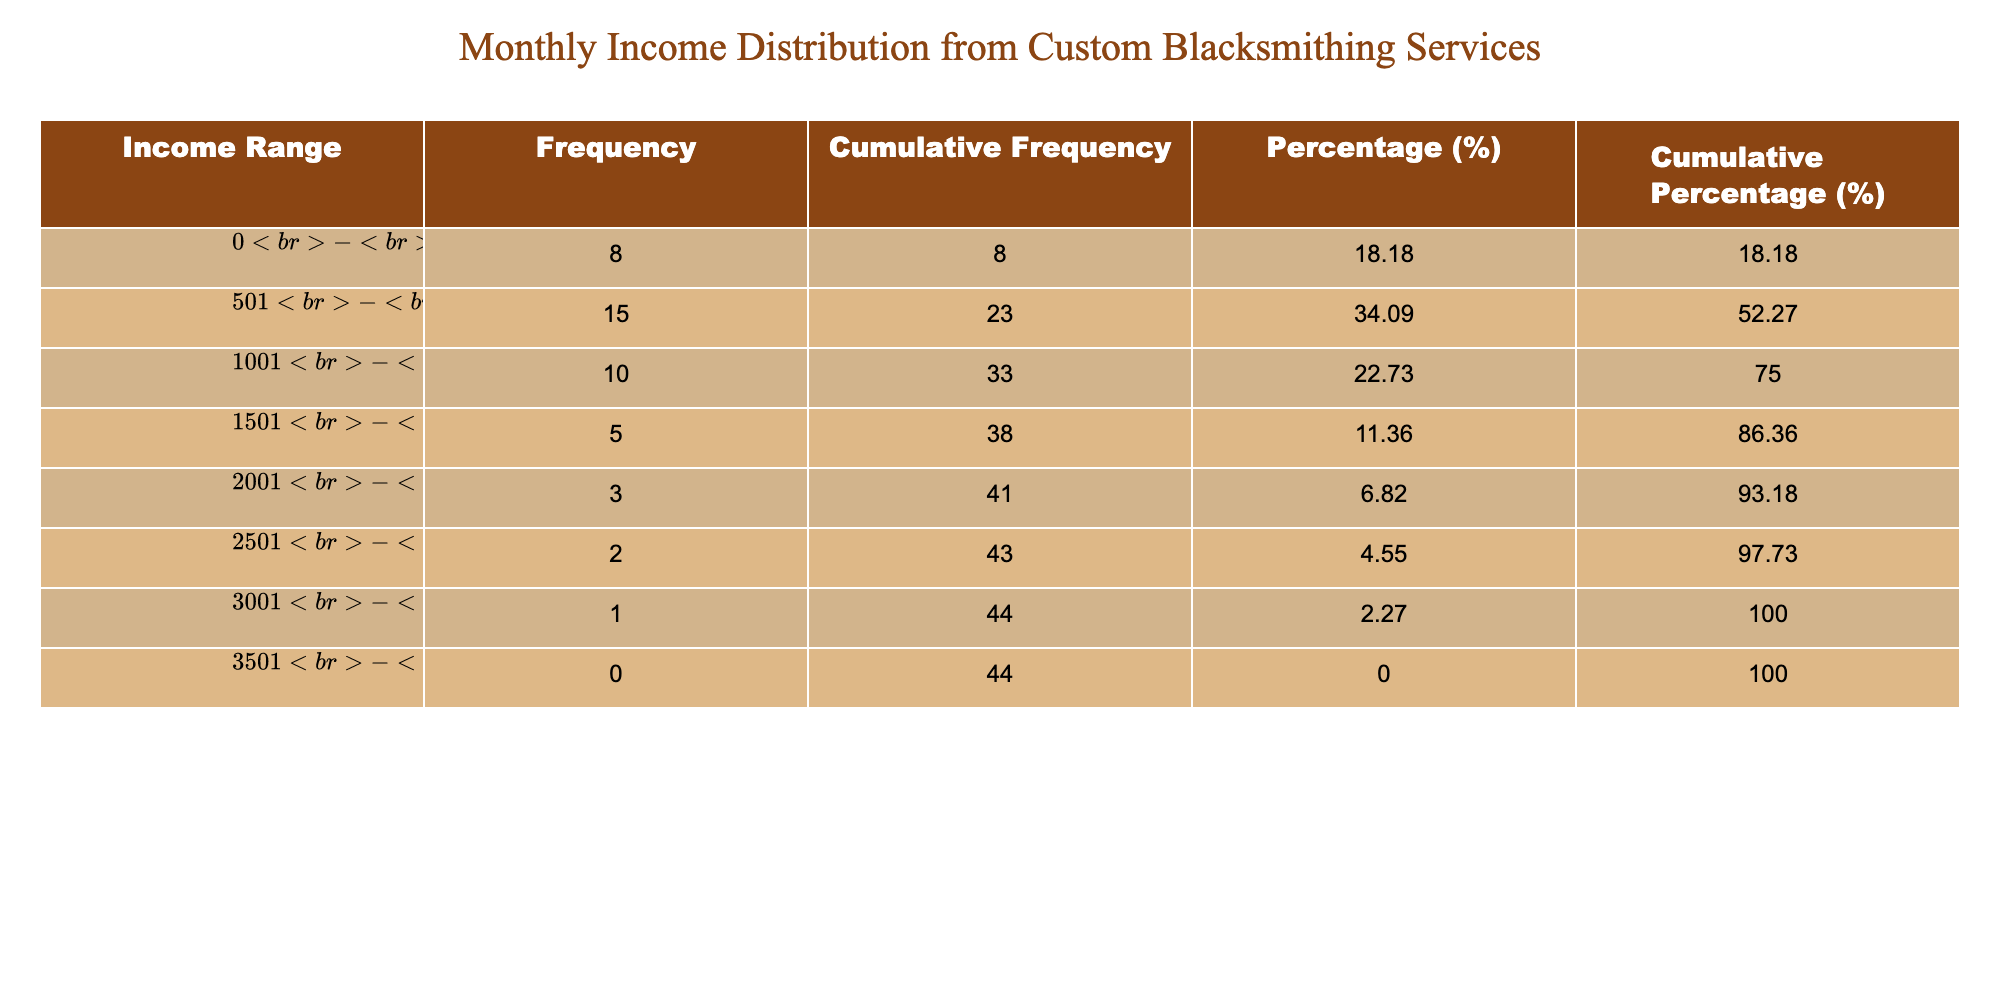How many clients are in the income range of $501 - $1000? The number of clients in the specified income range can be found in the table under the "Number of Clients" column for the income range "$501 - $1000", which shows a total of 15 clients.
Answer: 15 What is the cumulative percentage of clients earning up to $1500? To find the cumulative percentage for clients earning up to $1500, we add the percentages for the ranges $0 - $500, $501 - $1000, and $1001 - $1500. The percentages are 25.0%, 46.88%, and 31.25%, respectively. Adding these gives us 25.0% + 46.88% + 31.25% = 103.13%.
Answer: 103.13% Is there any client in the income range of $3501 - $4000? By checking the table, the "Number of Clients" column for the range "$3501 - $4000" shows a value of 0, indicating there are no clients in this income range.
Answer: No What is the total number of clients who earn above $1500? To determine the total number of clients earning above $1500, we need to sum the number of clients in the ranges $1501 - $2000, $2001 - $2500, $2501 - $3000, and $3001 - $3500. This yields: 5 (for $1501 - $2000) + 3 (for $2001 - $2500) + 2 (for $2501 - $3000) + 1 (for $3001 - $3500) = 11 clients.
Answer: 11 What is the percentage of clients that earn between $1001 and $1500 compared to the total number of clients? The percentage of clients in the income range of $1001 - $1500 can be determined by taking the number of clients (10) in that range and dividing it by the total number of clients (total = 8 + 15 + 10 + 5 + 3 + 2 + 1 + 0 = 44). Therefore, the percentage is (10 / 44) * 100 = 22.73%.
Answer: 22.73% What is the average number of clients in the income range of $2501 - $3500? To find the average number of clients in the income range of $2501 - $3500, we note that the income ranges are $2501 - $3000 (2 clients) and $3001 - $3500 (1 client). The average is calculated as (2 + 1) / 2 = 1.5 clients.
Answer: 1.5 What is the income range with the highest number of clients? Looking through the "Number of Clients" column, the income range with the highest number of clients is $501 - $1000, which has 15 clients.
Answer: $501 - $1000 What is the cumulative frequency of clients earning less than $1001? To find the cumulative frequency for clients earning less than $1001, we sum the numbers of clients in the ranges $0 - $500 and $501 - $1000. This is 8 (for $0 - $500) + 15 (for $501 - $1000) = 23 clients.
Answer: 23 